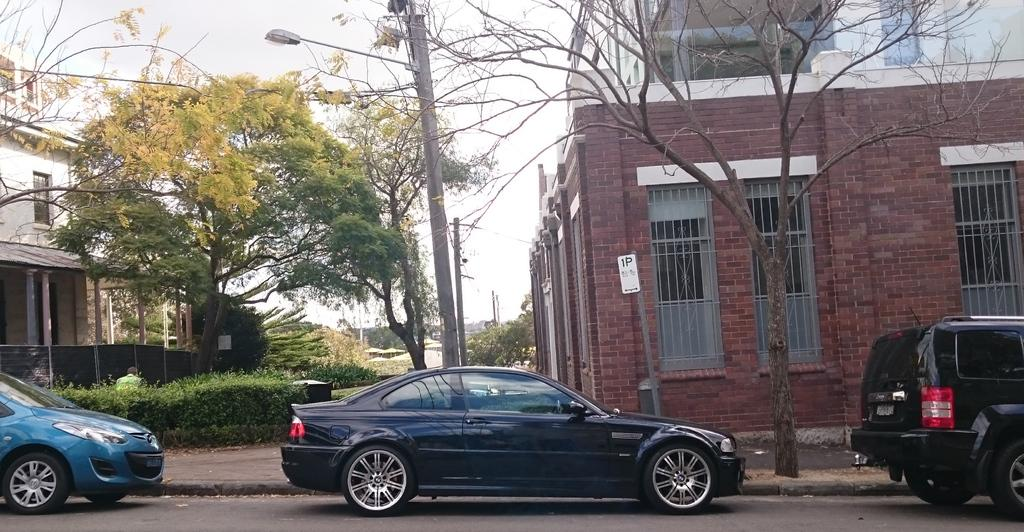What can be seen in the center of the image? There are cars on the road in the center of the image. What is visible in the background of the image? There are buildings and trees in the background of the image. Can you describe any specific object in the image? There is a light pole in the image. What is visible above the buildings and trees in the image? The sky is visible in the image. What type of clam is being cooked in the image? There is no clam or cooking activity present in the image. What is the frame made of in the image? There is no frame present in the image. 